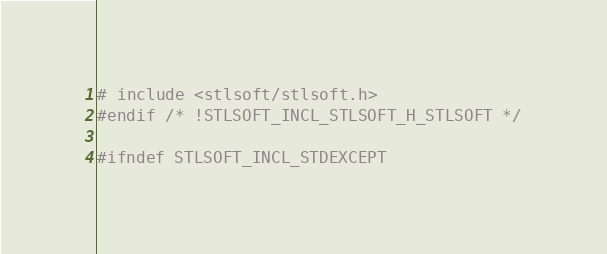Convert code to text. <code><loc_0><loc_0><loc_500><loc_500><_C++_># include <stlsoft/stlsoft.h>
#endif /* !STLSOFT_INCL_STLSOFT_H_STLSOFT */

#ifndef STLSOFT_INCL_STDEXCEPT</code> 